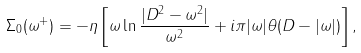Convert formula to latex. <formula><loc_0><loc_0><loc_500><loc_500>\Sigma _ { 0 } ( \omega ^ { + } ) = - \eta \left [ \omega \ln \frac { | D ^ { 2 } - \omega ^ { 2 } | } { \omega ^ { 2 } } + i \pi | \omega | \theta ( D - | \omega | ) \right ] ,</formula> 